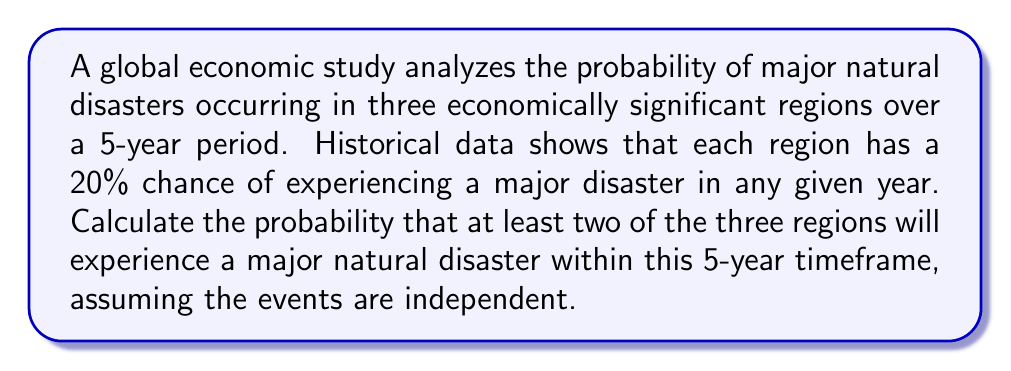Teach me how to tackle this problem. Let's approach this step-by-step using combinatorics and probability theory:

1) First, let's calculate the probability of a region experiencing at least one major disaster in 5 years:
   $P(\text{at least one disaster in 5 years}) = 1 - P(\text{no disasters in 5 years})$
   $= 1 - (0.8)^5 = 1 - 0.32768 = 0.67232$

2) Now, we can treat each region as a Bernoulli trial with p = 0.67232.

3) We want the probability of at least 2 out of 3 regions experiencing a disaster. This is equivalent to the probability of 2 or 3 regions experiencing a disaster.

4) We can use the binomial probability formula:
   $P(X = k) = \binom{n}{k} p^k (1-p)^{n-k}$
   where n = 3 (total regions), k = 2 or 3 (regions with disasters), and p = 0.67232

5) For exactly 2 regions:
   $P(X = 2) = \binom{3}{2} (0.67232)^2 (1-0.67232)^1$
   $= 3 \cdot 0.67232^2 \cdot 0.32768 = 0.4508$

6) For all 3 regions:
   $P(X = 3) = \binom{3}{3} (0.67232)^3 (1-0.67232)^0$
   $= 1 \cdot 0.67232^3 = 0.3040$

7) The total probability is the sum of these two probabilities:
   $P(\text{at least 2 regions}) = P(X = 2) + P(X = 3)$
   $= 0.4508 + 0.3040 = 0.7548$

Therefore, the probability that at least two of the three regions will experience a major natural disaster within the 5-year timeframe is approximately 0.7548 or 75.48%.
Answer: 0.7548 